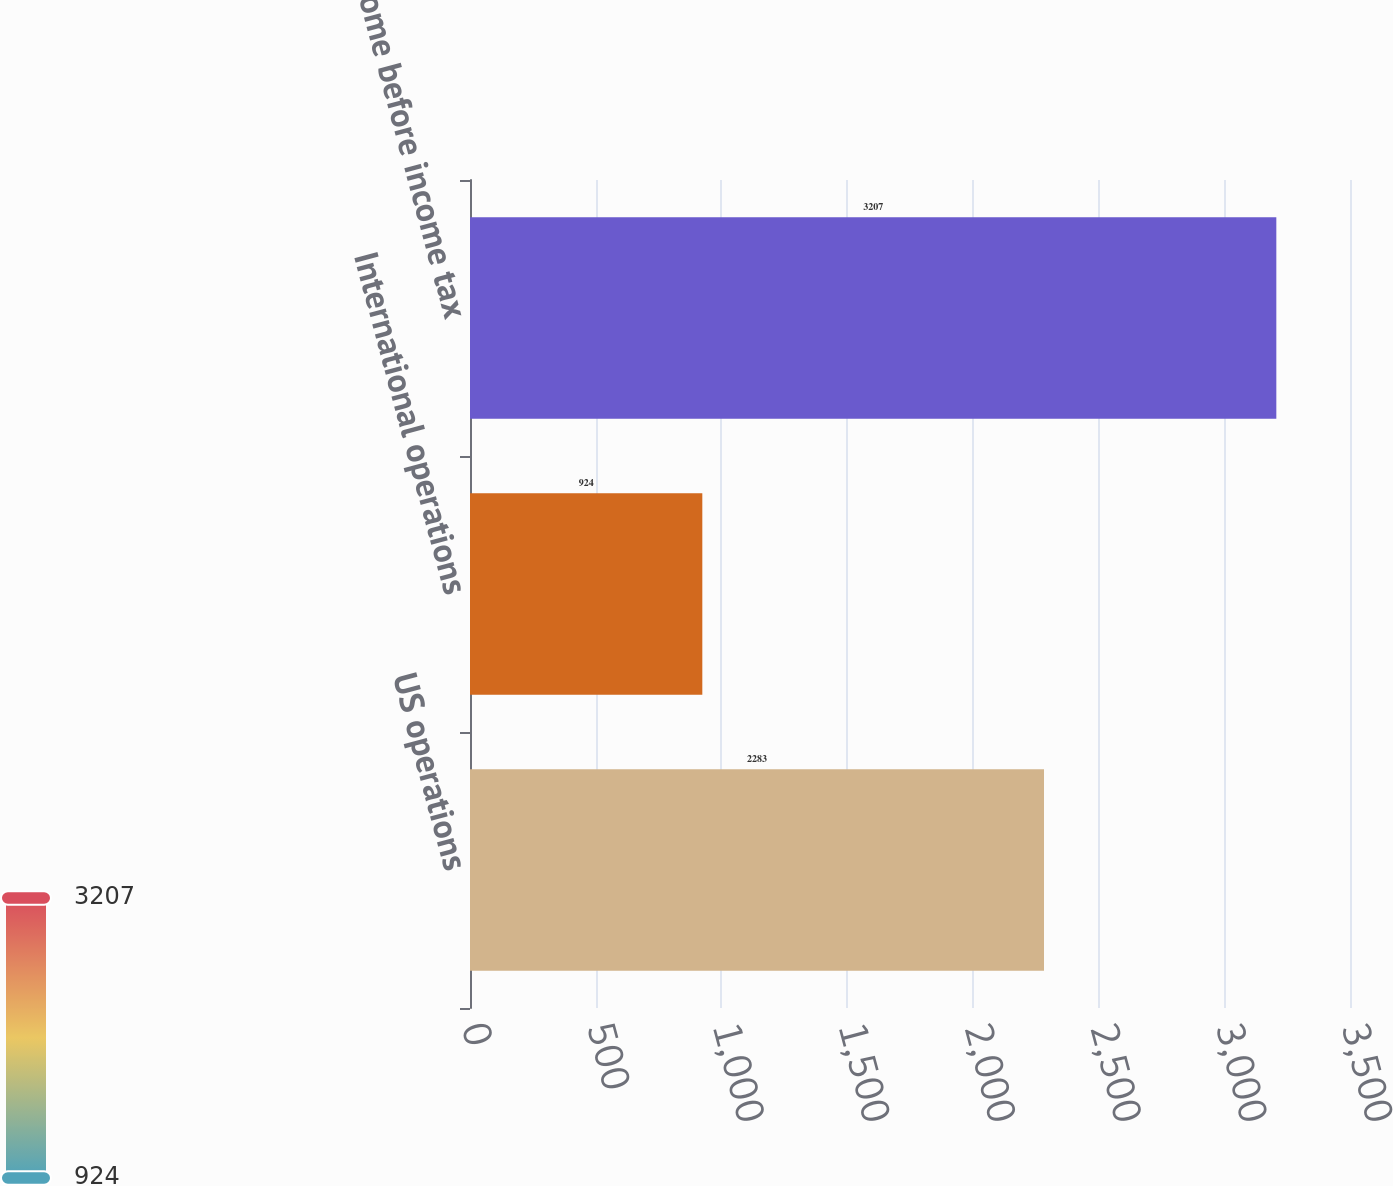Convert chart. <chart><loc_0><loc_0><loc_500><loc_500><bar_chart><fcel>US operations<fcel>International operations<fcel>Income before income tax<nl><fcel>2283<fcel>924<fcel>3207<nl></chart> 